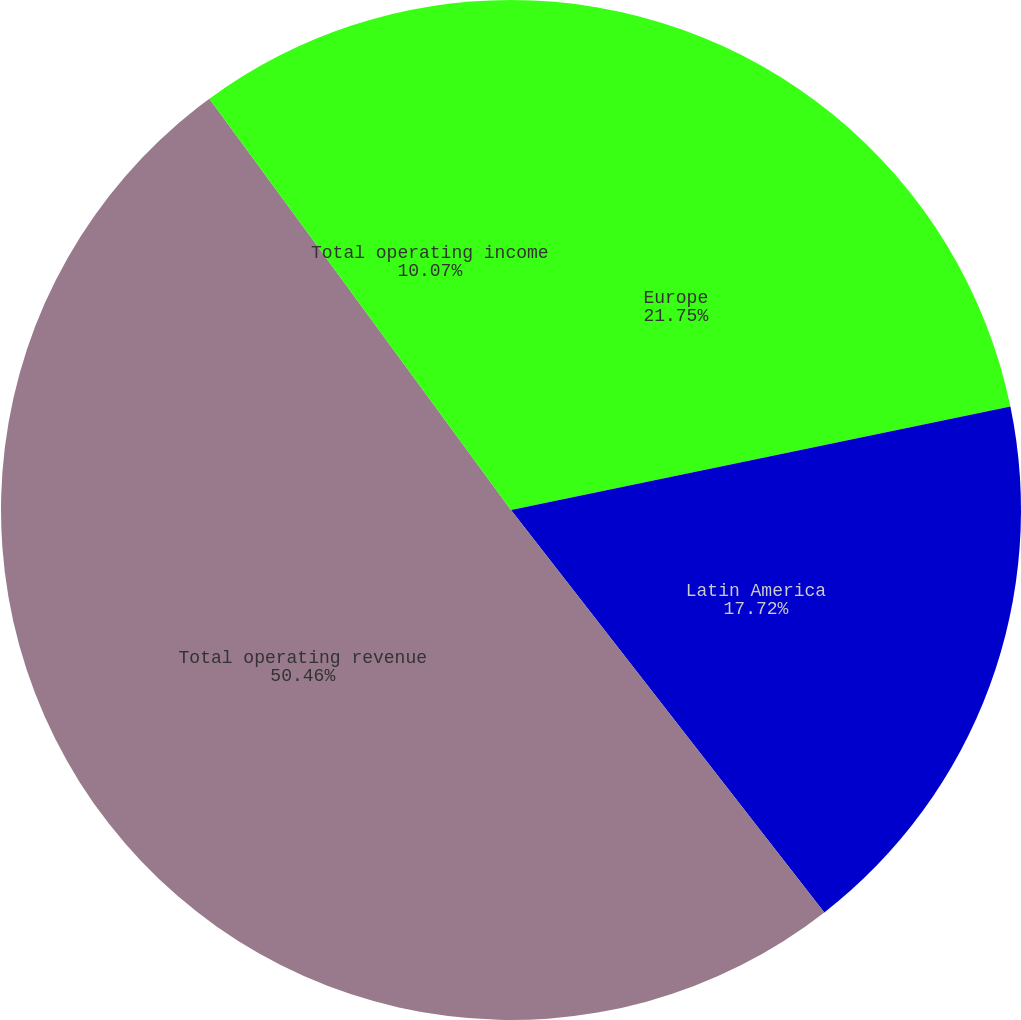Convert chart. <chart><loc_0><loc_0><loc_500><loc_500><pie_chart><fcel>Europe<fcel>Latin America<fcel>Total operating revenue<fcel>Total operating income<nl><fcel>21.75%<fcel>17.72%<fcel>50.46%<fcel>10.07%<nl></chart> 